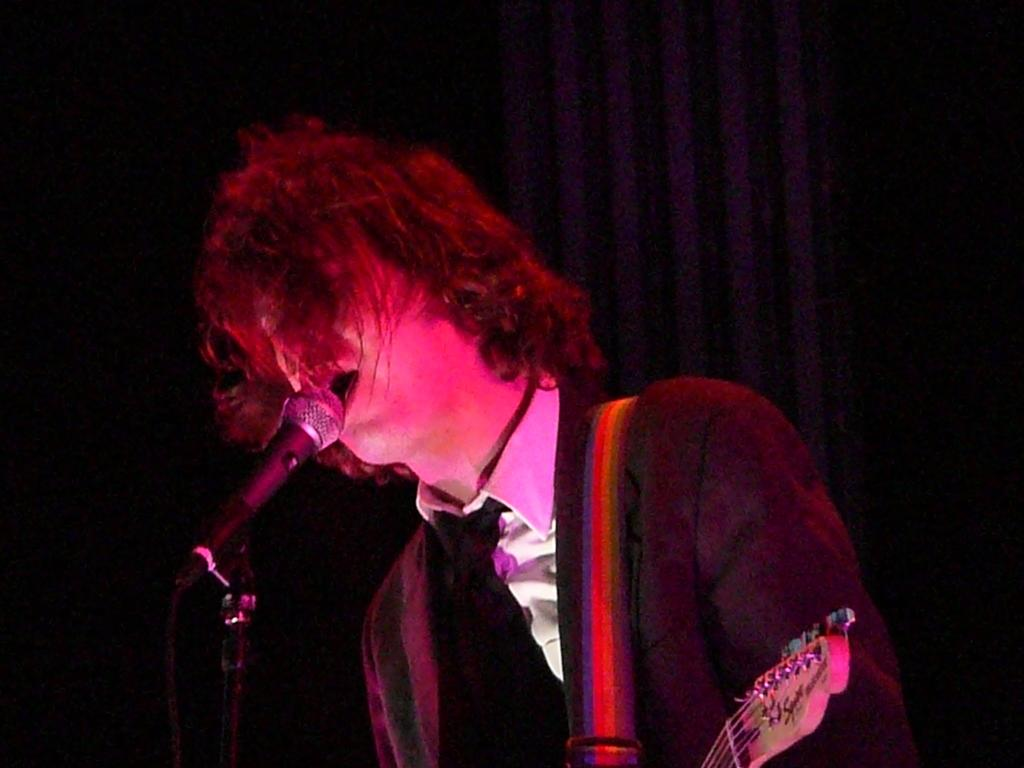What is the man in the image wearing? The man is wearing a black coat and a white shirt. What activity is the man engaged in? The man is singing and appears to be playing a guitar. What object is in front of the man? There is a microphone in front of the man. What can be seen in the background of the image? There are curtains in the background of the image. Can you see a river flowing behind the man in the image? No, there is no river visible in the image. What type of pen is the man holding while playing the guitar? The man is not holding a pen in the image; he is playing a guitar and singing. 